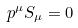<formula> <loc_0><loc_0><loc_500><loc_500>p ^ { \mu } S _ { \mu } = 0</formula> 